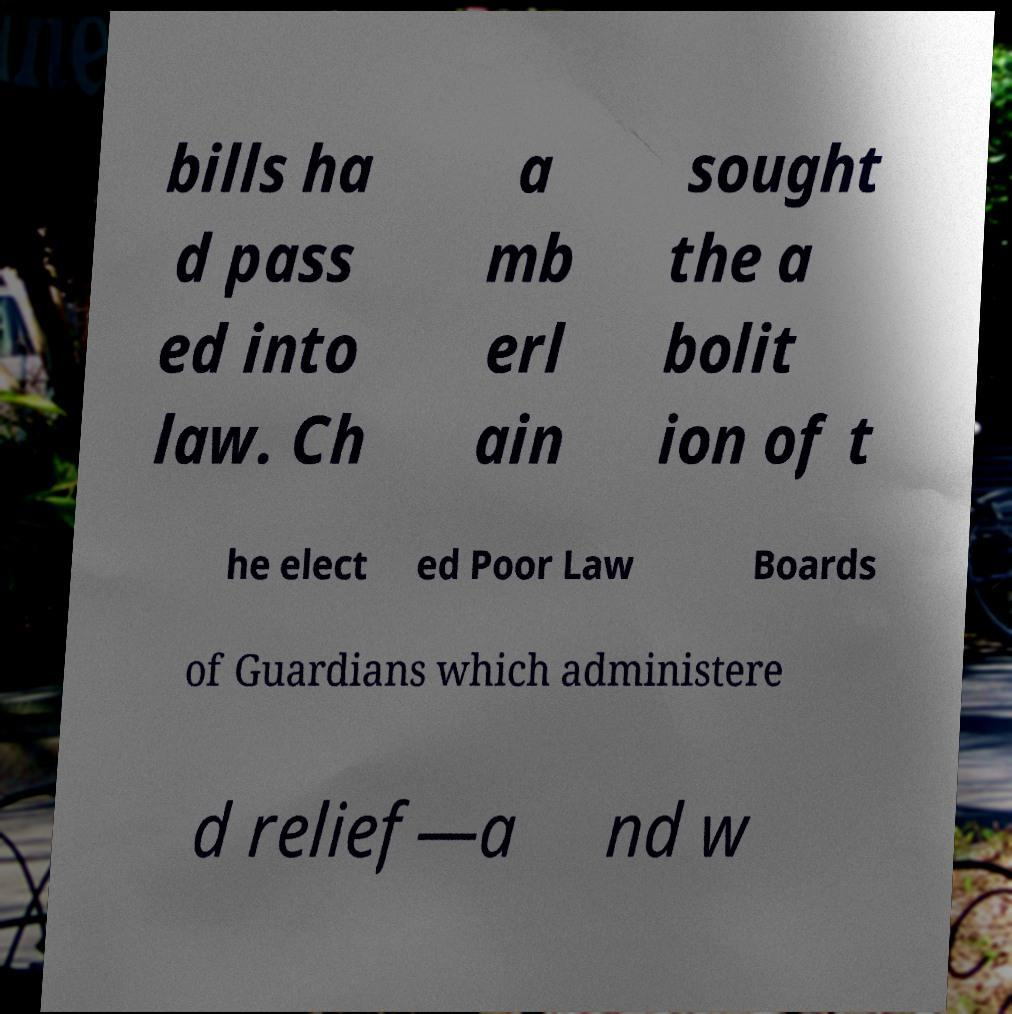I need the written content from this picture converted into text. Can you do that? bills ha d pass ed into law. Ch a mb erl ain sought the a bolit ion of t he elect ed Poor Law Boards of Guardians which administere d relief—a nd w 